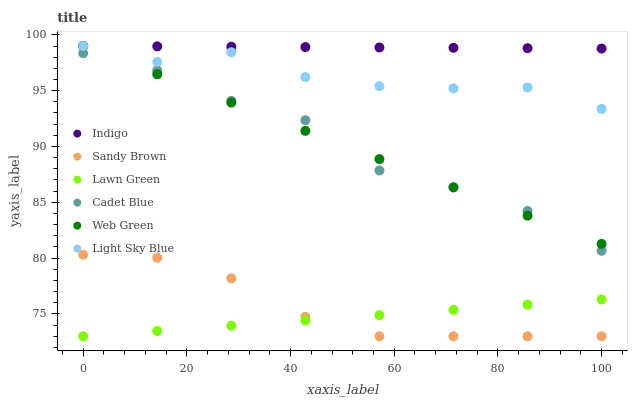Does Lawn Green have the minimum area under the curve?
Answer yes or no. Yes. Does Indigo have the maximum area under the curve?
Answer yes or no. Yes. Does Cadet Blue have the minimum area under the curve?
Answer yes or no. No. Does Cadet Blue have the maximum area under the curve?
Answer yes or no. No. Is Lawn Green the smoothest?
Answer yes or no. Yes. Is Cadet Blue the roughest?
Answer yes or no. Yes. Is Indigo the smoothest?
Answer yes or no. No. Is Indigo the roughest?
Answer yes or no. No. Does Lawn Green have the lowest value?
Answer yes or no. Yes. Does Cadet Blue have the lowest value?
Answer yes or no. No. Does Light Sky Blue have the highest value?
Answer yes or no. Yes. Does Cadet Blue have the highest value?
Answer yes or no. No. Is Sandy Brown less than Web Green?
Answer yes or no. Yes. Is Web Green greater than Sandy Brown?
Answer yes or no. Yes. Does Web Green intersect Cadet Blue?
Answer yes or no. Yes. Is Web Green less than Cadet Blue?
Answer yes or no. No. Is Web Green greater than Cadet Blue?
Answer yes or no. No. Does Sandy Brown intersect Web Green?
Answer yes or no. No. 